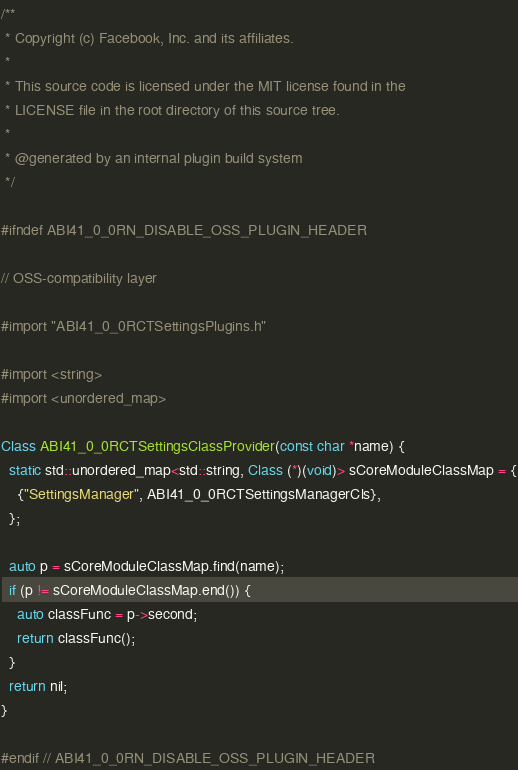Convert code to text. <code><loc_0><loc_0><loc_500><loc_500><_ObjectiveC_>/**
 * Copyright (c) Facebook, Inc. and its affiliates.
 *
 * This source code is licensed under the MIT license found in the
 * LICENSE file in the root directory of this source tree.
 *
 * @generated by an internal plugin build system
 */

#ifndef ABI41_0_0RN_DISABLE_OSS_PLUGIN_HEADER

// OSS-compatibility layer

#import "ABI41_0_0RCTSettingsPlugins.h"

#import <string>
#import <unordered_map>

Class ABI41_0_0RCTSettingsClassProvider(const char *name) {
  static std::unordered_map<std::string, Class (*)(void)> sCoreModuleClassMap = {
    {"SettingsManager", ABI41_0_0RCTSettingsManagerCls},
  };

  auto p = sCoreModuleClassMap.find(name);
  if (p != sCoreModuleClassMap.end()) {
    auto classFunc = p->second;
    return classFunc();
  }
  return nil;
}

#endif // ABI41_0_0RN_DISABLE_OSS_PLUGIN_HEADER
</code> 